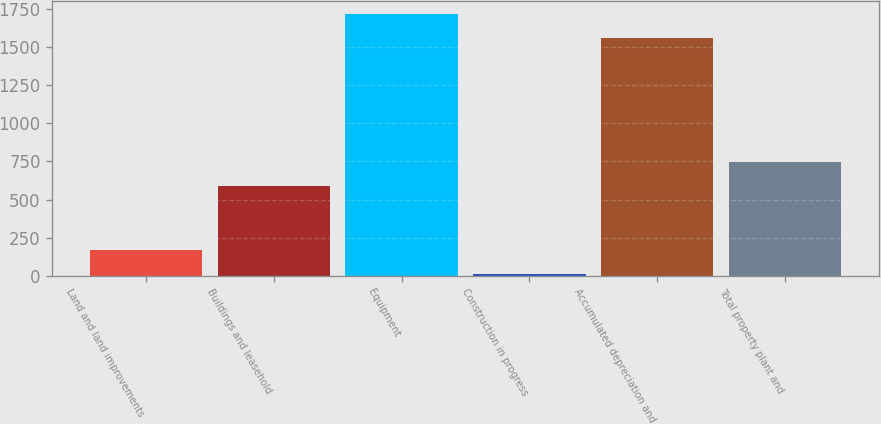Convert chart to OTSL. <chart><loc_0><loc_0><loc_500><loc_500><bar_chart><fcel>Land and land improvements<fcel>Buildings and leasehold<fcel>Equipment<fcel>Construction in progress<fcel>Accumulated depreciation and<fcel>Total property plant and<nl><fcel>168.4<fcel>591<fcel>1717.4<fcel>11<fcel>1560<fcel>748.4<nl></chart> 